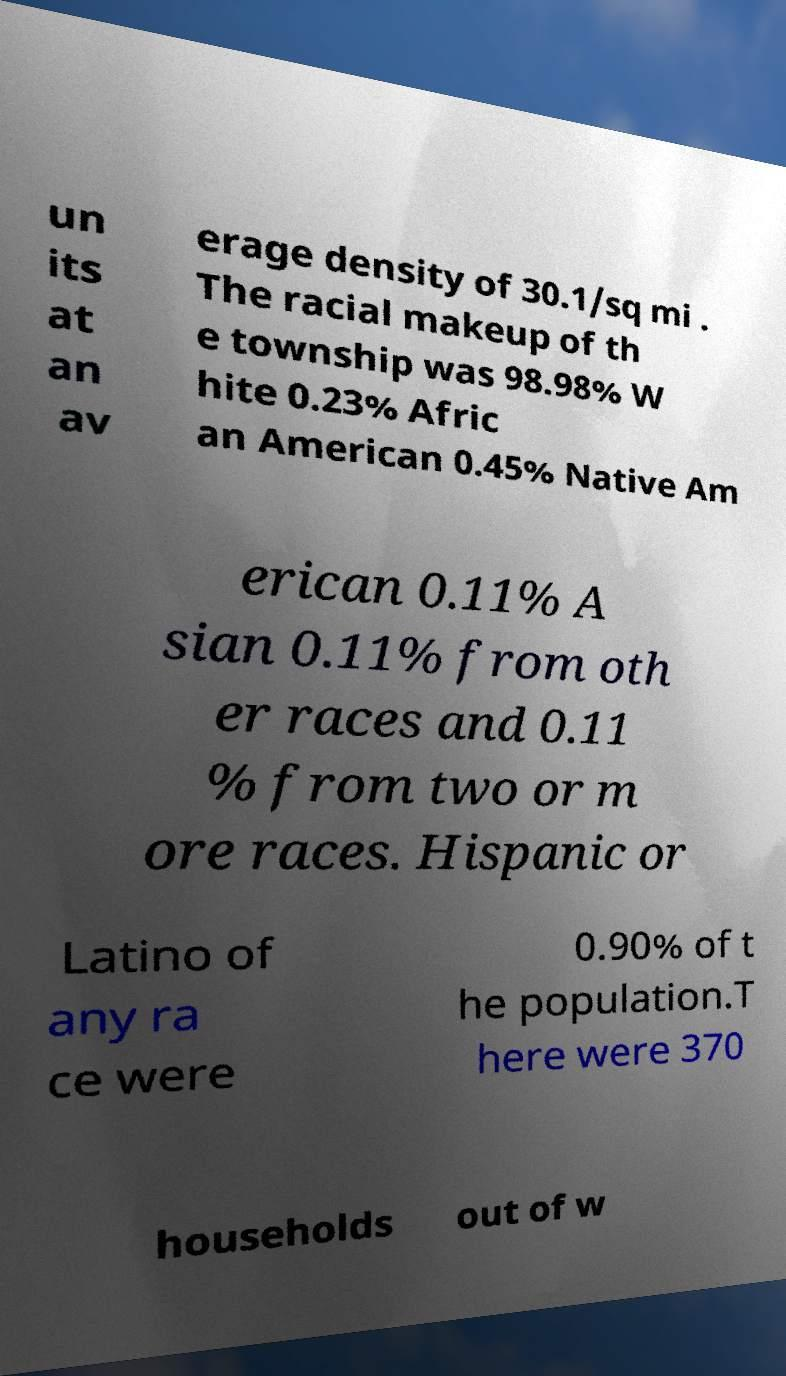Could you extract and type out the text from this image? un its at an av erage density of 30.1/sq mi . The racial makeup of th e township was 98.98% W hite 0.23% Afric an American 0.45% Native Am erican 0.11% A sian 0.11% from oth er races and 0.11 % from two or m ore races. Hispanic or Latino of any ra ce were 0.90% of t he population.T here were 370 households out of w 